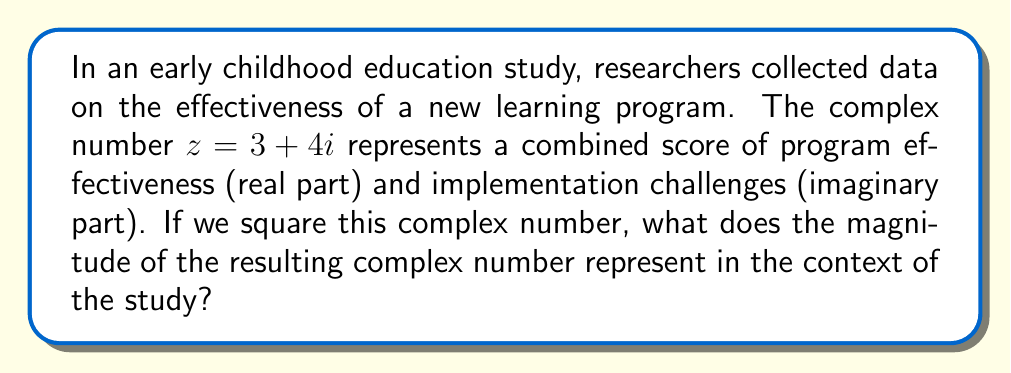Could you help me with this problem? Let's approach this step-by-step:

1) We start with the complex number $z = 3 + 4i$.

2) To square this number, we multiply it by itself:
   $z^2 = (3 + 4i)(3 + 4i)$

3) Using the FOIL method:
   $z^2 = 9 + 12i + 12i + 16i^2$

4) Simplify, remembering that $i^2 = -1$:
   $z^2 = 9 + 24i - 16 = -7 + 24i$

5) The resulting complex number is $-7 + 24i$.

6) To find the magnitude of this number, we use the formula:
   $|a + bi| = \sqrt{a^2 + b^2}$

7) In this case:
   $|-7 + 24i| = \sqrt{(-7)^2 + 24^2} = \sqrt{49 + 576} = \sqrt{625} = 25$

8) In the context of the study, the magnitude represents the overall impact of the program, combining both its effectiveness and the challenges faced during implementation.

9) The square of the original complex number amplifies both the positive effects and the challenges, and the magnitude of this squared number gives us a single value that encapsulates this amplified overall impact.
Answer: 25 (representing the amplified overall impact of the program) 